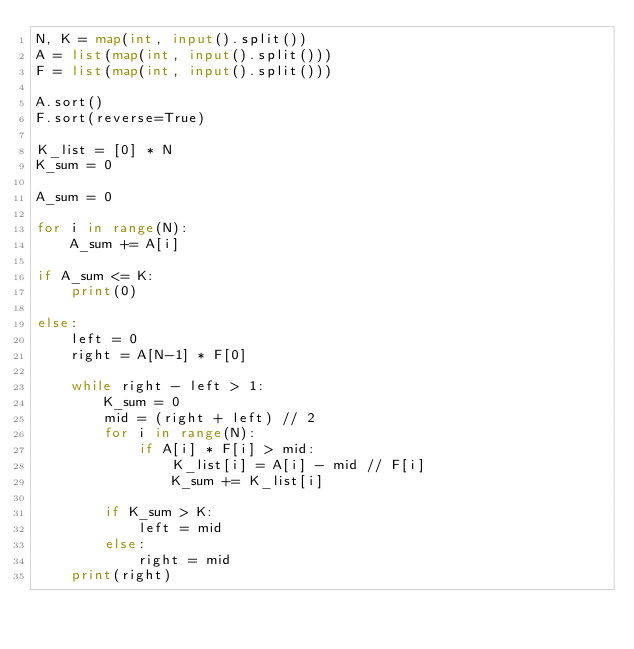Convert code to text. <code><loc_0><loc_0><loc_500><loc_500><_Python_>N, K = map(int, input().split())
A = list(map(int, input().split()))
F = list(map(int, input().split()))

A.sort()
F.sort(reverse=True)

K_list = [0] * N
K_sum = 0

A_sum = 0

for i in range(N):
    A_sum += A[i]

if A_sum <= K:
    print(0)

else:
    left = 0
    right = A[N-1] * F[0]

    while right - left > 1:
        K_sum = 0
        mid = (right + left) // 2
        for i in range(N):
            if A[i] * F[i] > mid:
                K_list[i] = A[i] - mid // F[i]
                K_sum += K_list[i]

        if K_sum > K:
            left = mid
        else:
            right = mid
    print(right)
</code> 